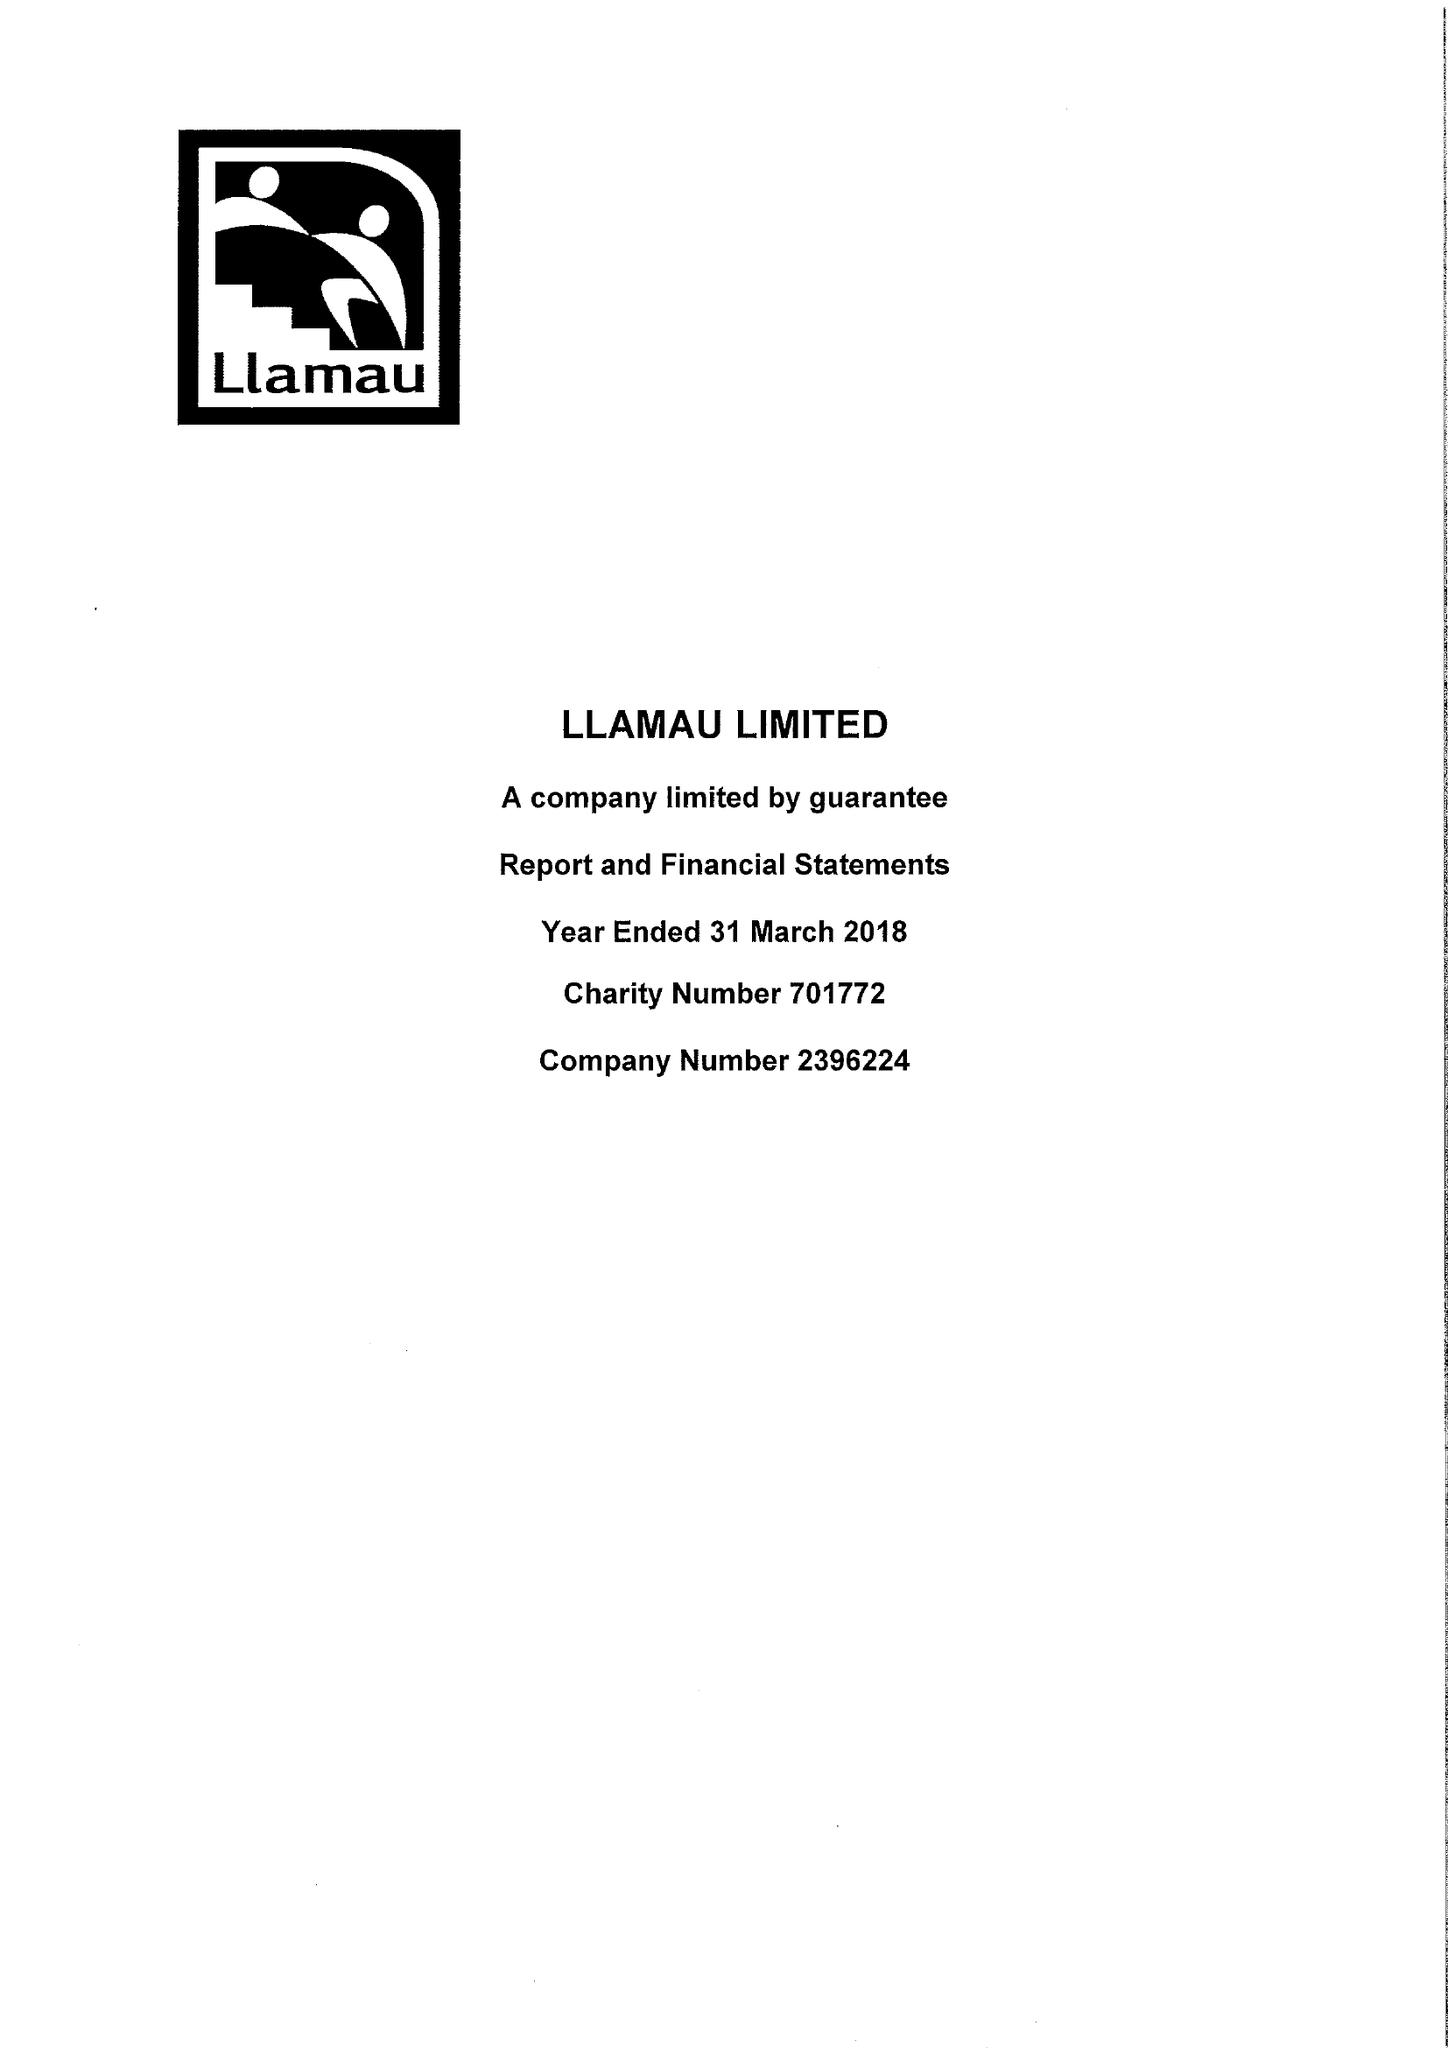What is the value for the charity_number?
Answer the question using a single word or phrase. 701772 